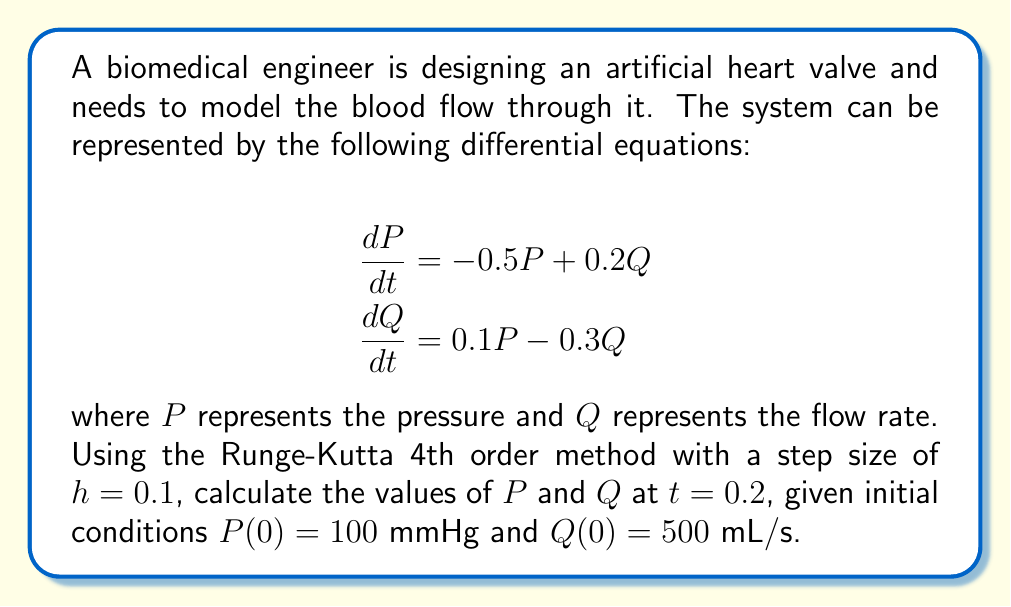Can you answer this question? To solve this system of differential equations using the Runge-Kutta 4th order method, we need to follow these steps:

1) Define the functions for $dP/dt$ and $dQ/dt$:
   $$f_1(t,P,Q) = -0.5P + 0.2Q$$
   $$f_2(t,P,Q) = 0.1P - 0.3Q$$

2) Apply the Runge-Kutta 4th order method:
   For each step:
   $$\begin{align}
   k_1 &= hf(t_n, y_n) \\
   k_2 &= hf(t_n + \frac{h}{2}, y_n + \frac{k_1}{2}) \\
   k_3 &= hf(t_n + \frac{h}{2}, y_n + \frac{k_2}{2}) \\
   k_4 &= hf(t_n + h, y_n + k_3) \\
   y_{n+1} &= y_n + \frac{1}{6}(k_1 + 2k_2 + 2k_3 + k_4)
   \end{align}$$

3) Calculate for $t=0.1$ (first step):

   For $P$:
   $$\begin{align}
   k_1 &= 0.1(-0.5(100) + 0.2(500)) = 5 \\
   k_2 &= 0.1(-0.5(102.5) + 0.2(501.25)) = 4.875 \\
   k_3 &= 0.1(-0.5(102.4375) + 0.2(501.21875)) = 4.878125 \\
   k_4 &= 0.1(-0.5(104.878125) + 0.2(502.4390625)) = 4.7573828125 \\
   P_1 &= 100 + \frac{1}{6}(5 + 2(4.875) + 2(4.878125) + 4.7573828125) = 104.8776041667
   \end{align}$$

   For $Q$:
   $$\begin{align}
   k_1 &= 0.1(0.1(100) - 0.3(500)) = -14 \\
   k_2 &= 0.1(0.1(102.5) - 0.3(493)) = -13.765 \\
   k_3 &= 0.1(0.1(102.4375) - 0.3(493.1175)) = -13.769375 \\
   k_4 &= 0.1(0.1(104.878125) - 0.3(486.2306875)) = -13.5400546875 \\
   Q_1 &= 500 + \frac{1}{6}(-14 + 2(-13.765) + 2(-13.769375) + -13.5400546875) = 486.2681770833
   \end{align}$$

4) Repeat the process for $t=0.2$ (second step) using $P_1$ and $Q_1$ as initial values.

   For $P$:
   $$\begin{align}
   k_1 &= 0.1(-0.5(104.8776041667) + 0.2(486.2681770833)) = 4.5208333333 \\
   k_2 &= 0.1(-0.5(107.1380208333) + 0.2(488.5285937500)) = 4.4010416667 \\
   k_3 &= 0.1(-0.5(107.0781250000) + 0.2(488.4687500000)) = 4.4031250000 \\
   k_4 &= 0.1(-0.5(109.2807291667) + 0.2(490.6713020833)) = 4.2838541667 \\
   P_2 &= 104.8776041667 + \frac{1}{6}(4.5208333333 + 2(4.4010416667) + 2(4.4031250000) + 4.2838541667) = 109.2817256673
   \end{align}$$

   For $Q$:
   $$\begin{align}
   k_1 &= 0.1(0.1(104.8776041667) - 0.3(486.2681770833)) = -13.3027343750 \\
   k_2 &= 0.1(0.1(107.1380208333) - 0.3(479.6168098958)) = -13.0744791667 \\
   k_3 &= 0.1(0.1(107.0781250000) - 0.3(479.7309375000)) = -13.0815625000 \\
   k_4 &= 0.1(0.1(109.2807291667) - 0.3(473.1865885417)) = -12.8597005208 \\
   Q_2 &= 486.2681770833 + \frac{1}{6}(-13.3027343750 + 2(-13.0744791667) + 2(-13.0815625000) + -12.8597005208) = 473.1869506836
   \end{align}$$
Answer: $P(0.2) \approx 109.28$ mmHg, $Q(0.2) \approx 473.19$ mL/s 